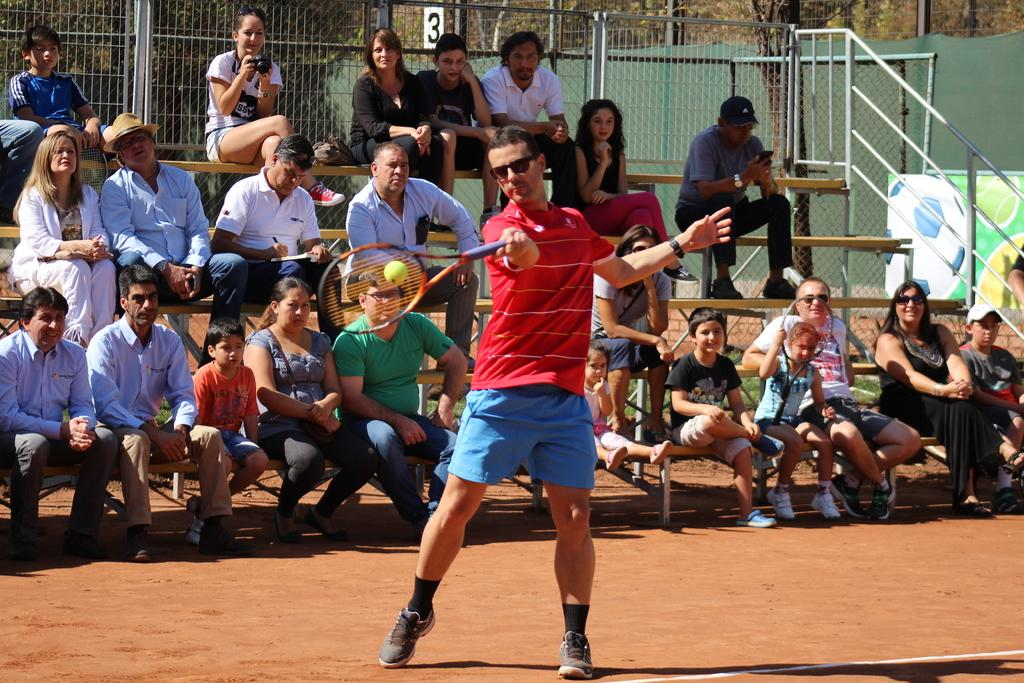<image>
Create a compact narrative representing the image presented. A man swings a tennis racket, people in the number three grand stand watch. 